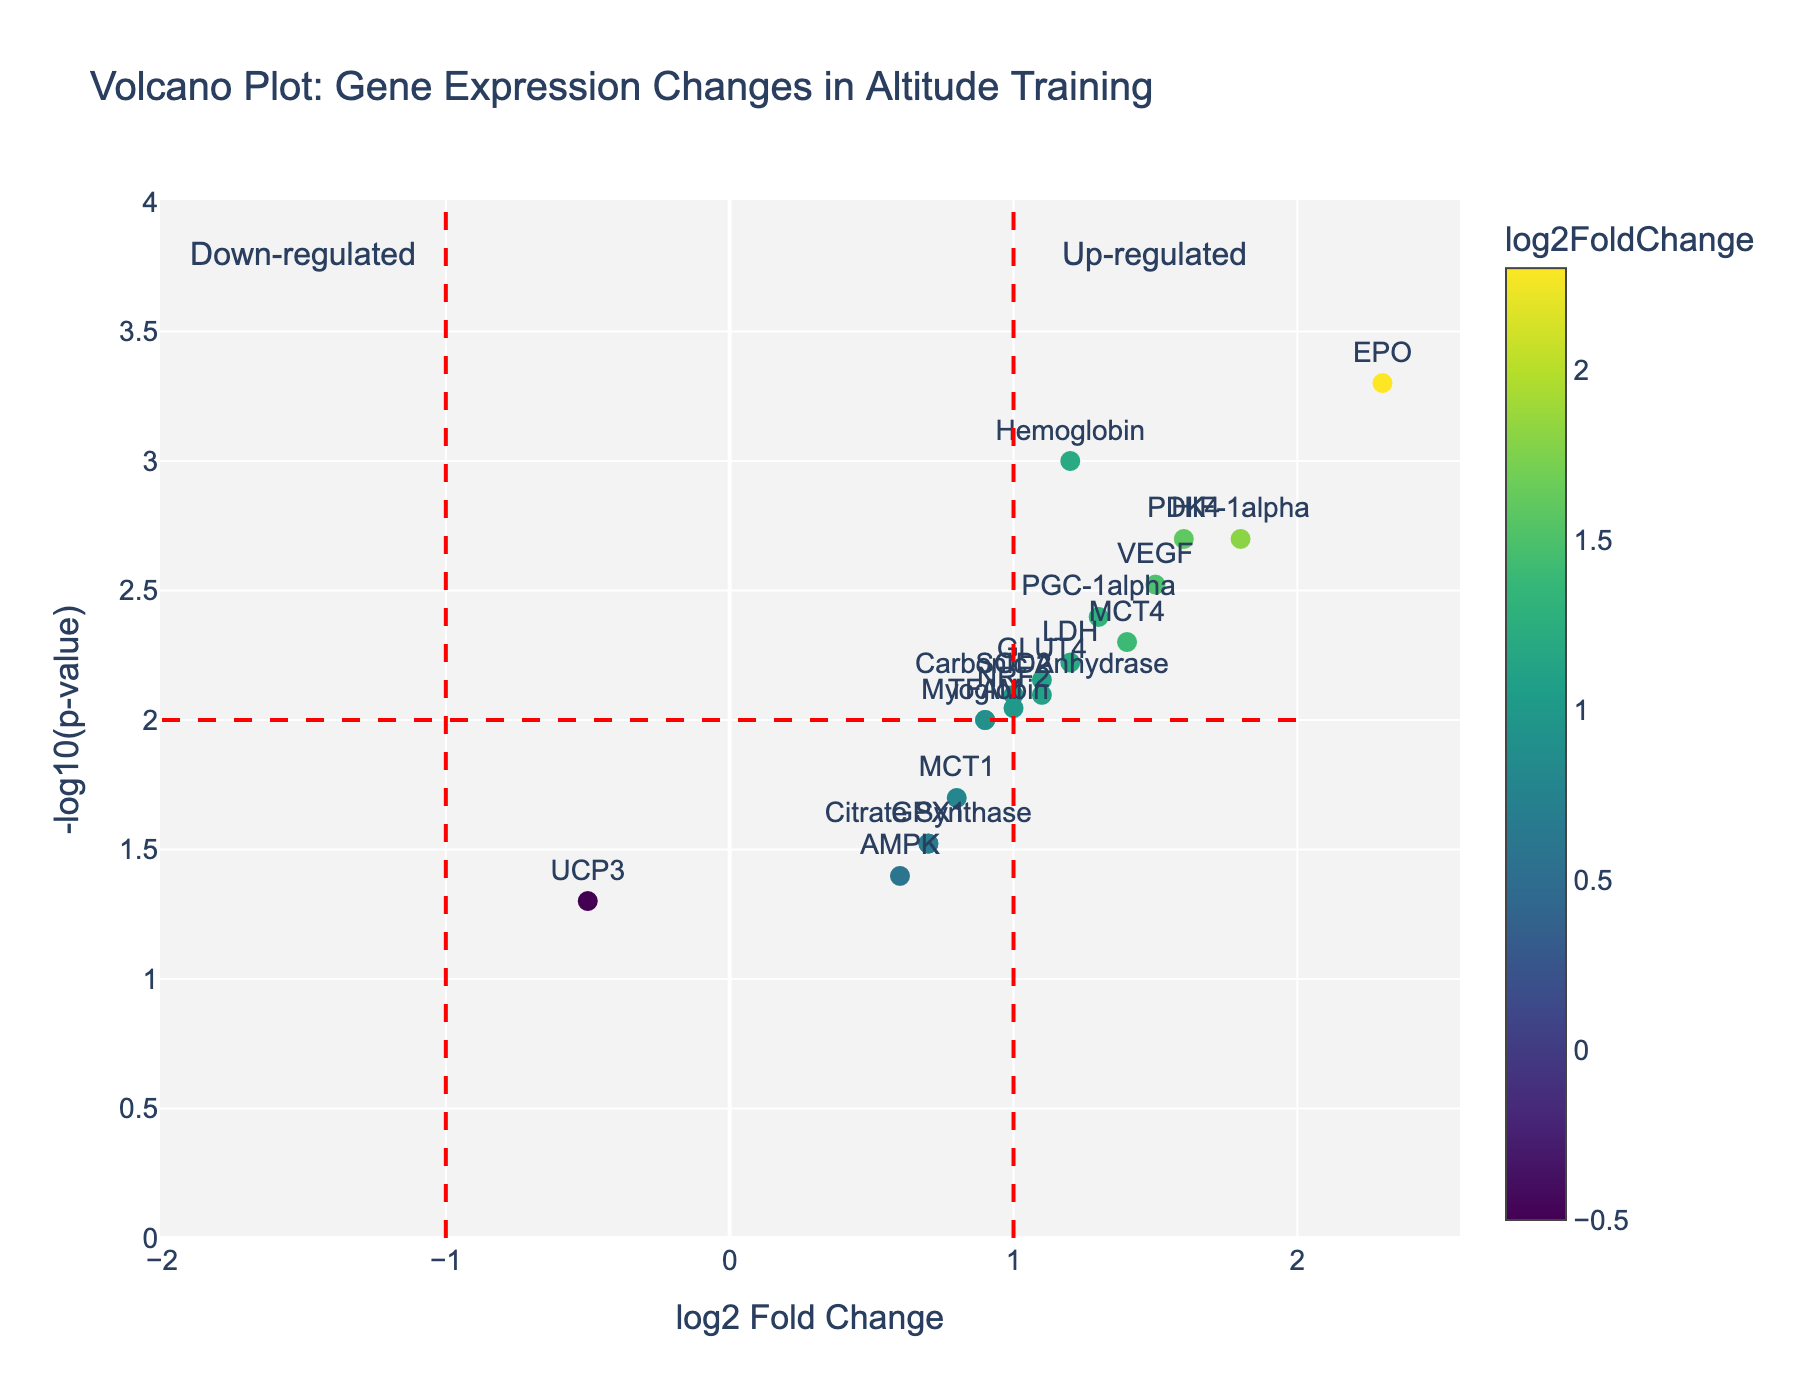Which gene has the highest log2FoldChange and how significant is this change? The label "EPO" has the highest log2FoldChange value of 2.3 as indicated by its position on the x-axis farthest to the right and a y-axis value corresponding to -log10(0.0005) indicating high significance.
Answer: EPO, highly significant Which gene has the smallest log2FoldChange? The label "UCP3" is positioned furthest to the left on the x-axis with a log2FoldChange value of -0.5.
Answer: UCP3 How many genes have a p-value smaller than 0.005? Looking at the y-axis (-log10(p-value)), any gene above y = 2 (since -log10(0.005) ≈ 2.3) has a p-value smaller than 0.005. These genes are Hemoglobin, EPO, HIF-1alpha, VEGF, and MCT4, totaling 5 genes.
Answer: 5 What does the red dashed line represent along the x-axis at log2FoldChange = 1? The red dashed line at x = 1 indicates a threshold for up-regulation of gene expression. Any gene to the right of this line is considered significantly up-regulated.
Answer: Threshold for up-regulation Which gene is up-regulated and has a log2FoldChange close to 1.5? The gene "VEGF" is located near the x = 1.5 mark on the x-axis and is up-regulated.
Answer: VEGF Are there any genes that are down-regulated and significant? Observing the left side beyond the threshold at log2FoldChange = -1, there is no data point, indicating no significant down-regulation.
Answer: No Which gene has a high fold change but is relatively less significant compared to others? "PDK4" has a log2FoldChange of 1.6 (high) but appears lower on the y-axis compared to EPO or HIF-1alpha, indicating it is less significant than these genes.
Answer: PDK4 What general trend can you observe about genes with log2FoldChange values greater than 1? Most genes with log2FoldChange values greater than 1 appear to be significantly up-regulated with high -log10(p-value), indicating a clear trend of up-regulation in response to altitude training.
Answer: Significant up-regulation 